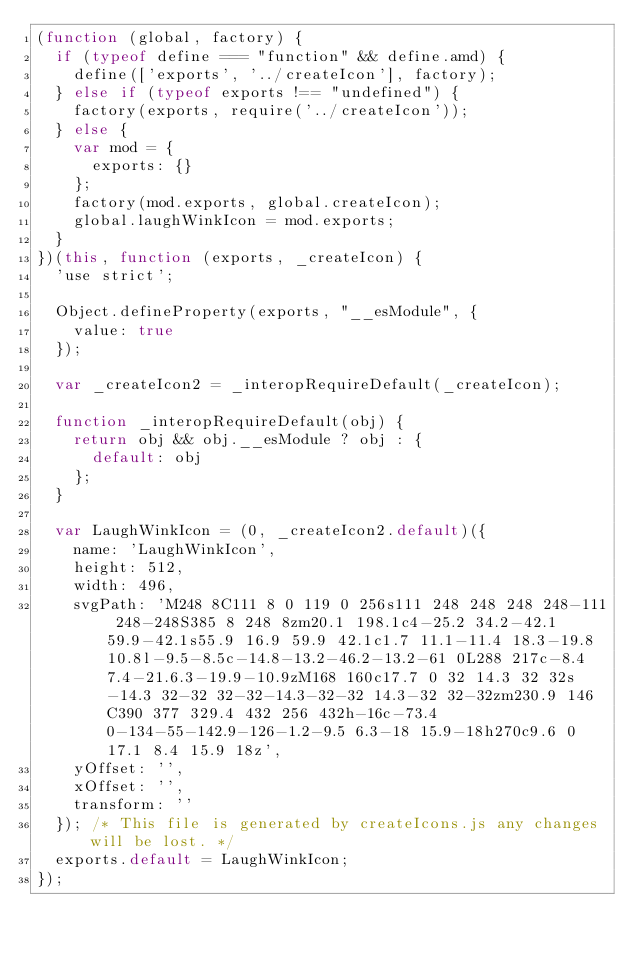Convert code to text. <code><loc_0><loc_0><loc_500><loc_500><_JavaScript_>(function (global, factory) {
  if (typeof define === "function" && define.amd) {
    define(['exports', '../createIcon'], factory);
  } else if (typeof exports !== "undefined") {
    factory(exports, require('../createIcon'));
  } else {
    var mod = {
      exports: {}
    };
    factory(mod.exports, global.createIcon);
    global.laughWinkIcon = mod.exports;
  }
})(this, function (exports, _createIcon) {
  'use strict';

  Object.defineProperty(exports, "__esModule", {
    value: true
  });

  var _createIcon2 = _interopRequireDefault(_createIcon);

  function _interopRequireDefault(obj) {
    return obj && obj.__esModule ? obj : {
      default: obj
    };
  }

  var LaughWinkIcon = (0, _createIcon2.default)({
    name: 'LaughWinkIcon',
    height: 512,
    width: 496,
    svgPath: 'M248 8C111 8 0 119 0 256s111 248 248 248 248-111 248-248S385 8 248 8zm20.1 198.1c4-25.2 34.2-42.1 59.9-42.1s55.9 16.9 59.9 42.1c1.7 11.1-11.4 18.3-19.8 10.8l-9.5-8.5c-14.8-13.2-46.2-13.2-61 0L288 217c-8.4 7.4-21.6.3-19.9-10.9zM168 160c17.7 0 32 14.3 32 32s-14.3 32-32 32-32-14.3-32-32 14.3-32 32-32zm230.9 146C390 377 329.4 432 256 432h-16c-73.4 0-134-55-142.9-126-1.2-9.5 6.3-18 15.9-18h270c9.6 0 17.1 8.4 15.9 18z',
    yOffset: '',
    xOffset: '',
    transform: ''
  }); /* This file is generated by createIcons.js any changes will be lost. */
  exports.default = LaughWinkIcon;
});</code> 